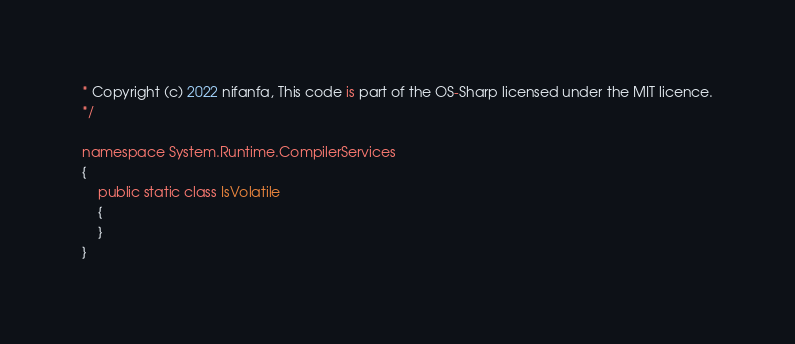Convert code to text. <code><loc_0><loc_0><loc_500><loc_500><_C#_>* Copyright (c) 2022 nifanfa, This code is part of the OS-Sharp licensed under the MIT licence.
*/

namespace System.Runtime.CompilerServices
{
    public static class IsVolatile
    {
    }
}
</code> 